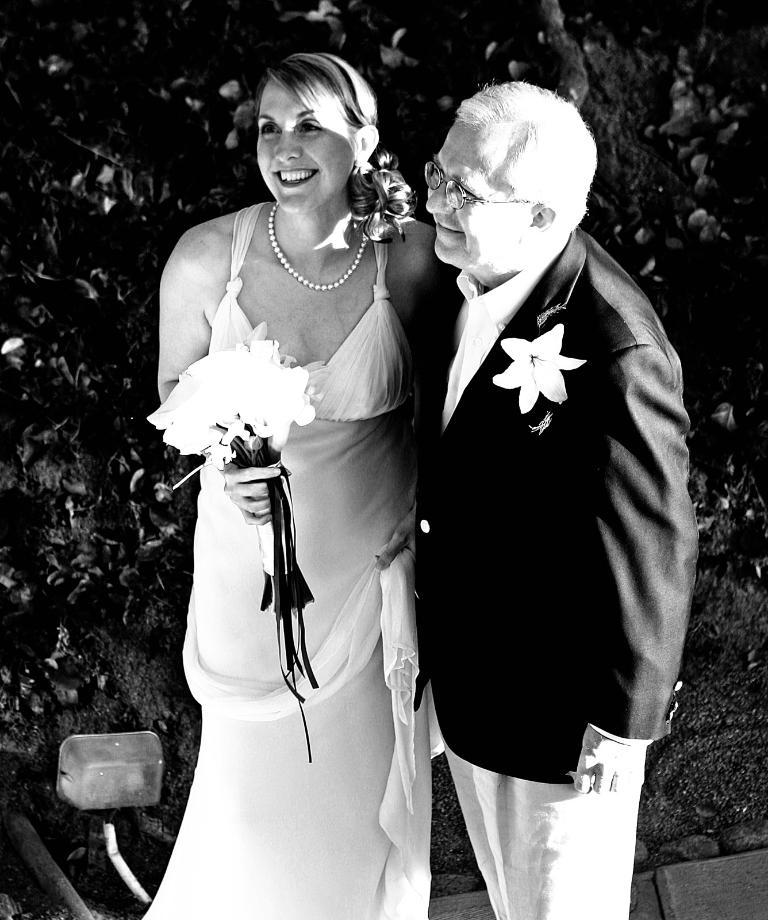Who is present in the image? There is a man and a woman in the image. What are the facial expressions of the people in the image? Both the man and woman are smiling in the image. What is the woman holding in her hand? The woman is holding flowers in her hand. What type of vegetation can be seen in the image? There are plants visible in the image. What is the price of the scarf the man is wearing in the image? There is no scarf visible in the image, and therefore no price can be determined. How much jelly is on the woman's plate in the image? There is no jelly present in the image. 